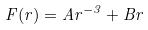Convert formula to latex. <formula><loc_0><loc_0><loc_500><loc_500>F ( r ) = A r ^ { - 3 } + B r</formula> 